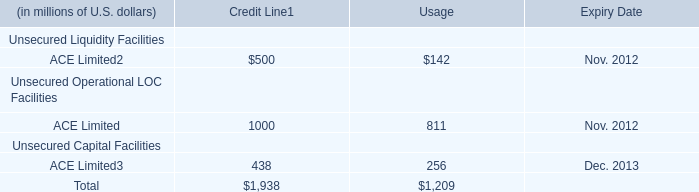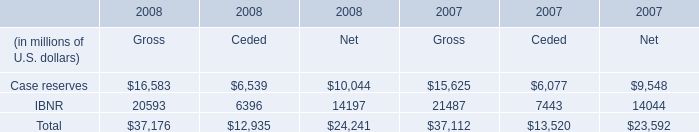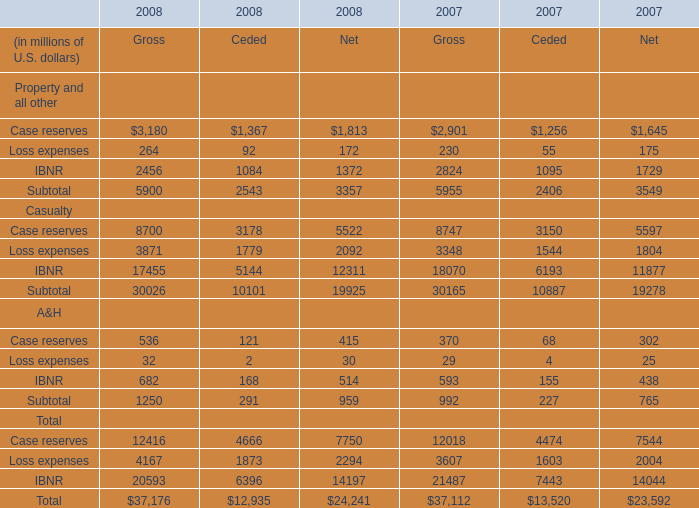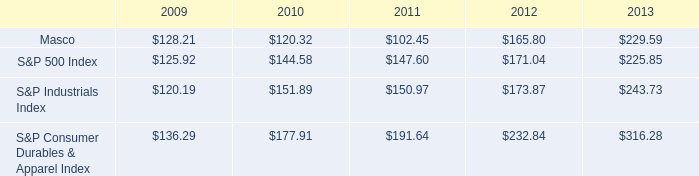what was the percent of the increase in the performance of s&p 500 index from 2009 to 2010 
Computations: ((144.58 / 125.92) / 125.92)
Answer: 0.00912. 